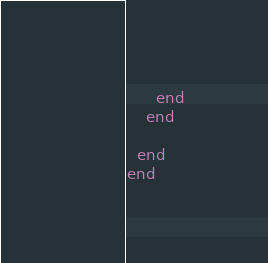Convert code to text. <code><loc_0><loc_0><loc_500><loc_500><_Ruby_>      end
    end

  end
end
</code> 